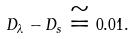Convert formula to latex. <formula><loc_0><loc_0><loc_500><loc_500>D _ { \lambda } - D _ { s } \cong 0 . 0 1 .</formula> 